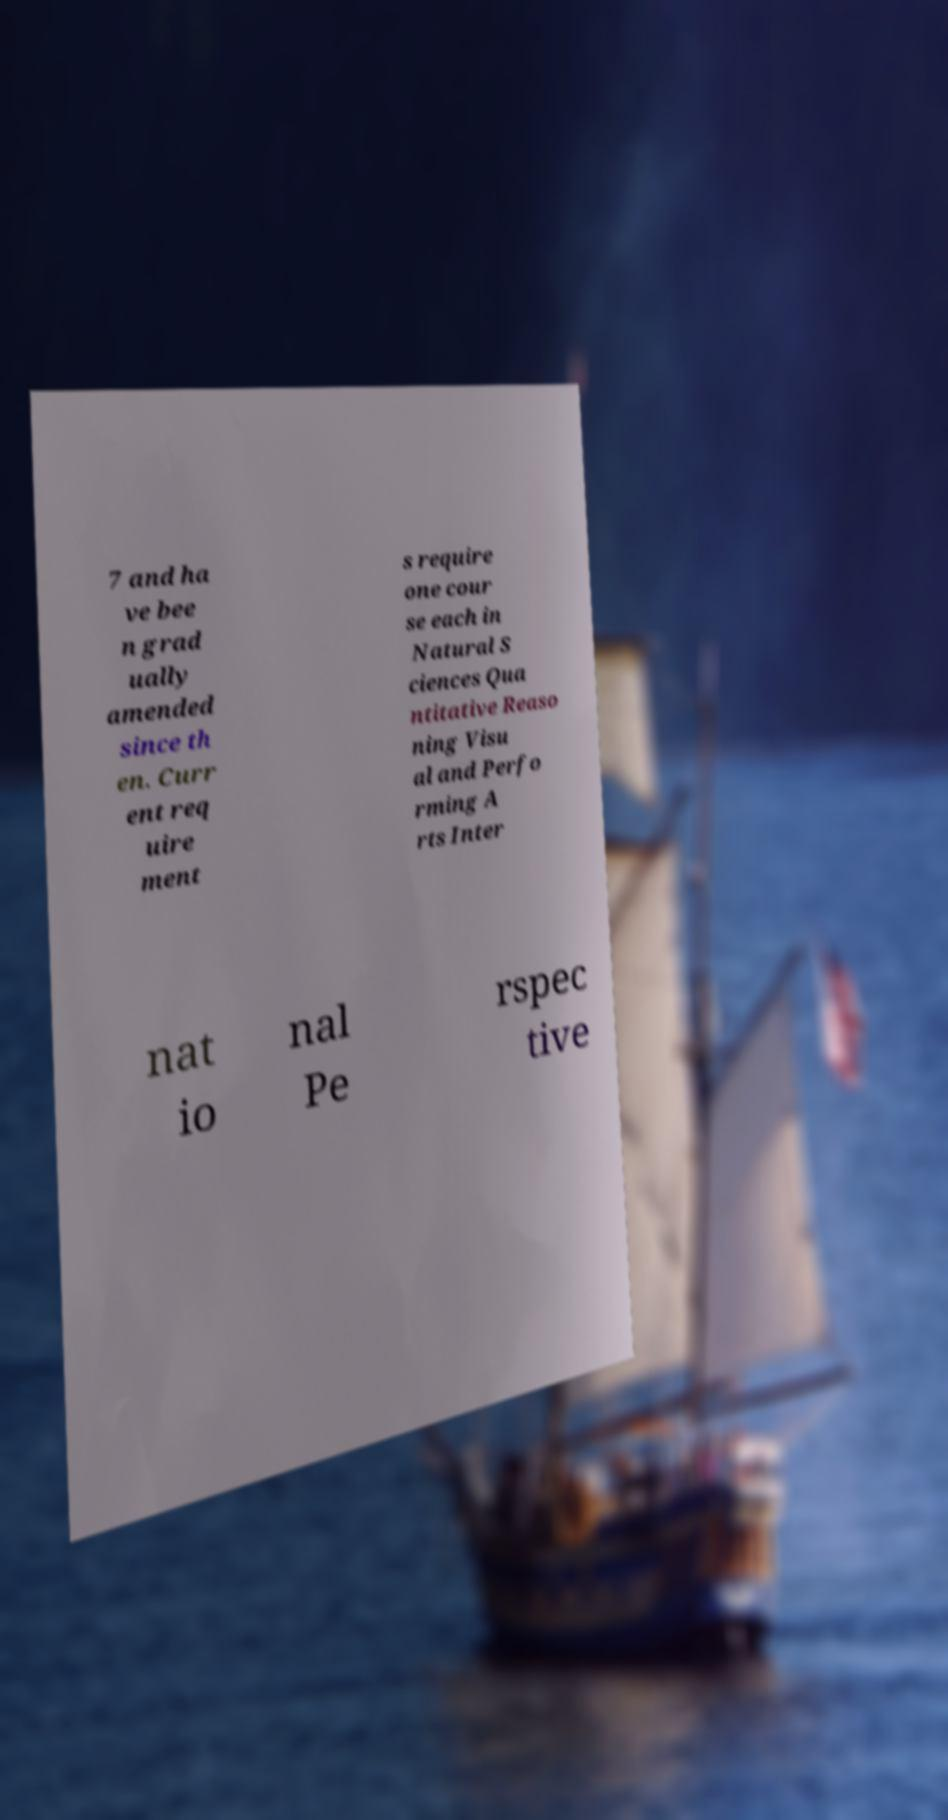There's text embedded in this image that I need extracted. Can you transcribe it verbatim? 7 and ha ve bee n grad ually amended since th en. Curr ent req uire ment s require one cour se each in Natural S ciences Qua ntitative Reaso ning Visu al and Perfo rming A rts Inter nat io nal Pe rspec tive 